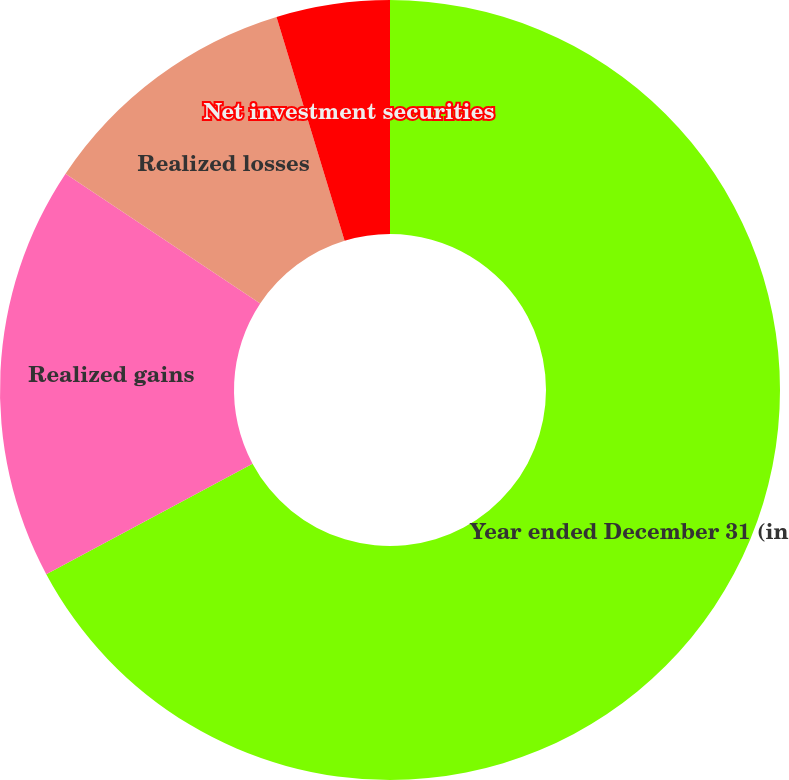<chart> <loc_0><loc_0><loc_500><loc_500><pie_chart><fcel>Year ended December 31 (in<fcel>Realized gains<fcel>Realized losses<fcel>Net investment securities<nl><fcel>67.17%<fcel>17.19%<fcel>10.94%<fcel>4.7%<nl></chart> 